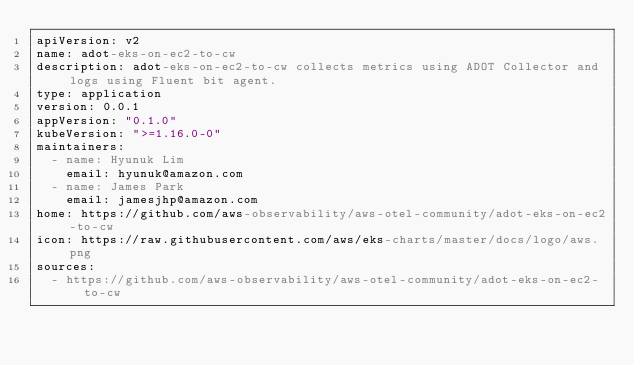Convert code to text. <code><loc_0><loc_0><loc_500><loc_500><_YAML_>apiVersion: v2
name: adot-eks-on-ec2-to-cw
description: adot-eks-on-ec2-to-cw collects metrics using ADOT Collector and logs using Fluent bit agent.
type: application
version: 0.0.1
appVersion: "0.1.0"
kubeVersion: ">=1.16.0-0"
maintainers:
  - name: Hyunuk Lim
    email: hyunuk@amazon.com
  - name: James Park
    email: jamesjhp@amazon.com
home: https://github.com/aws-observability/aws-otel-community/adot-eks-on-ec2-to-cw
icon: https://raw.githubusercontent.com/aws/eks-charts/master/docs/logo/aws.png
sources:
  - https://github.com/aws-observability/aws-otel-community/adot-eks-on-ec2-to-cw
</code> 